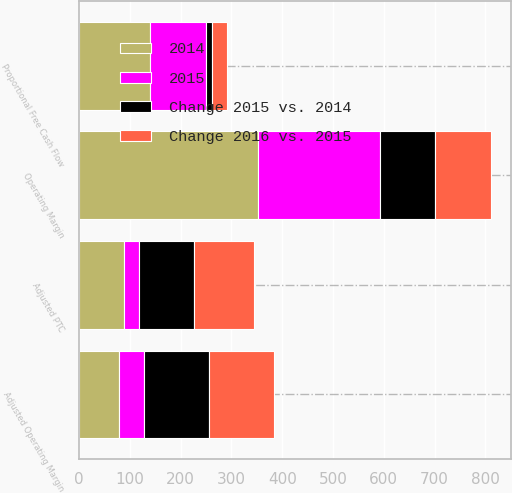Convert chart. <chart><loc_0><loc_0><loc_500><loc_500><stacked_bar_chart><ecel><fcel>Operating Margin<fcel>Adjusted Operating Margin<fcel>Adjusted PTC<fcel>Proportional Free Cash Flow<nl><fcel>2015<fcel>239<fcel>49<fcel>29<fcel>110<nl><fcel>Change 2016 vs. 2015<fcel>109<fcel>128<fcel>118<fcel>29<nl><fcel>Change 2015 vs. 2014<fcel>109<fcel>127<fcel>108<fcel>13<nl><fcel>2014<fcel>353<fcel>79<fcel>89<fcel>139<nl></chart> 